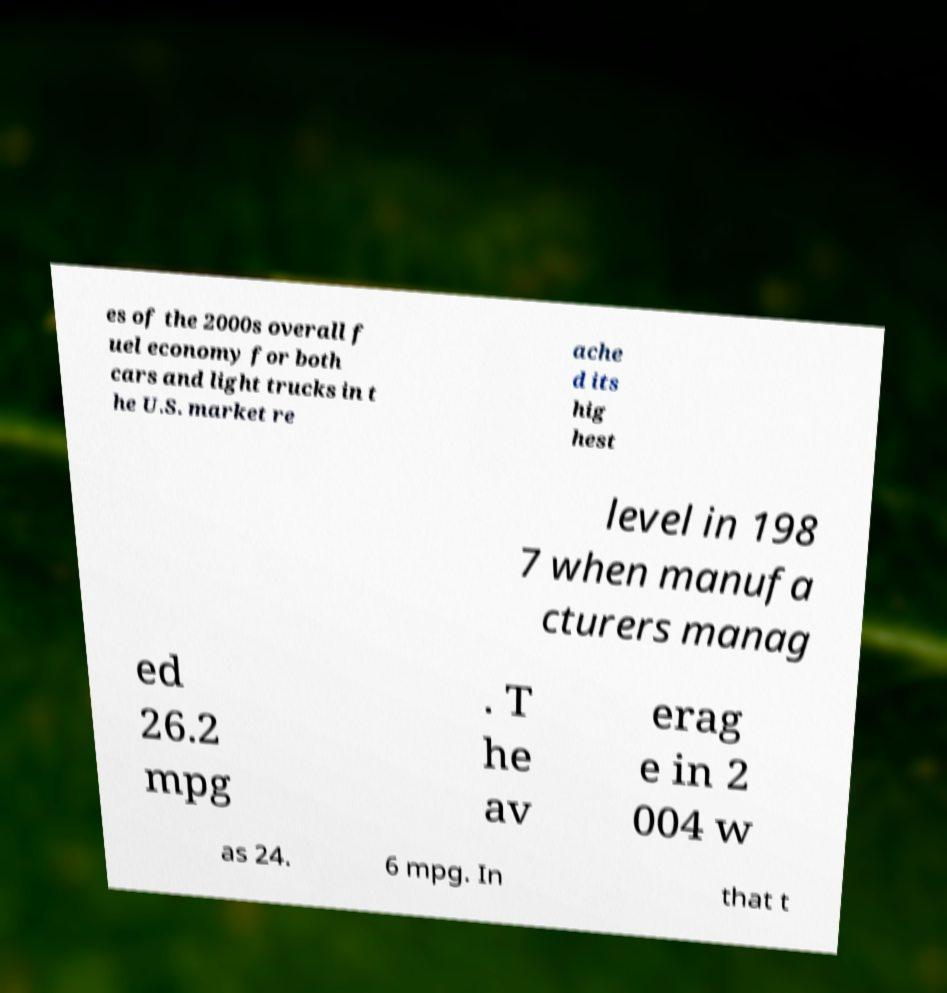Can you accurately transcribe the text from the provided image for me? es of the 2000s overall f uel economy for both cars and light trucks in t he U.S. market re ache d its hig hest level in 198 7 when manufa cturers manag ed 26.2 mpg . T he av erag e in 2 004 w as 24. 6 mpg. In that t 